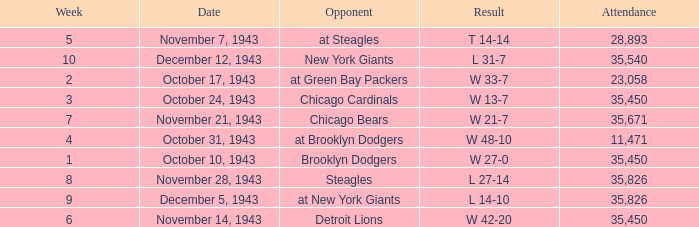What is the lowest attendance that has a week less than 4, and w 13-7 as the result? 35450.0. 